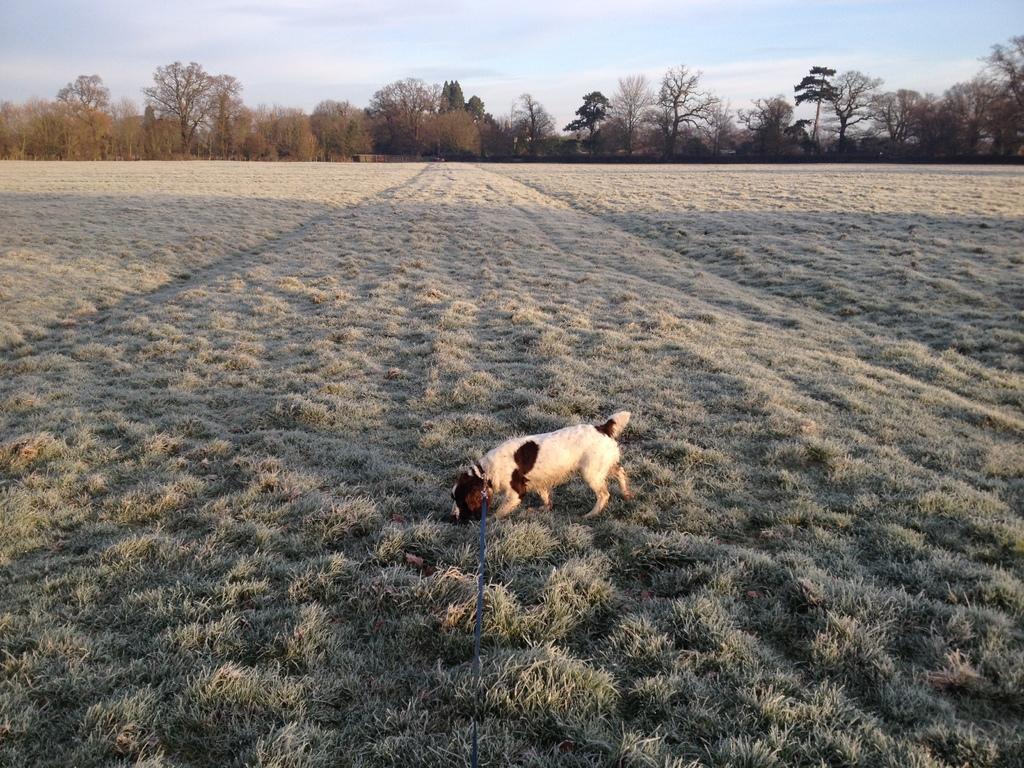Describe this image in one or two sentences. In this picture we can see a dog on the ground, with a belt on it and in the background we can see grass, trees, sky. 